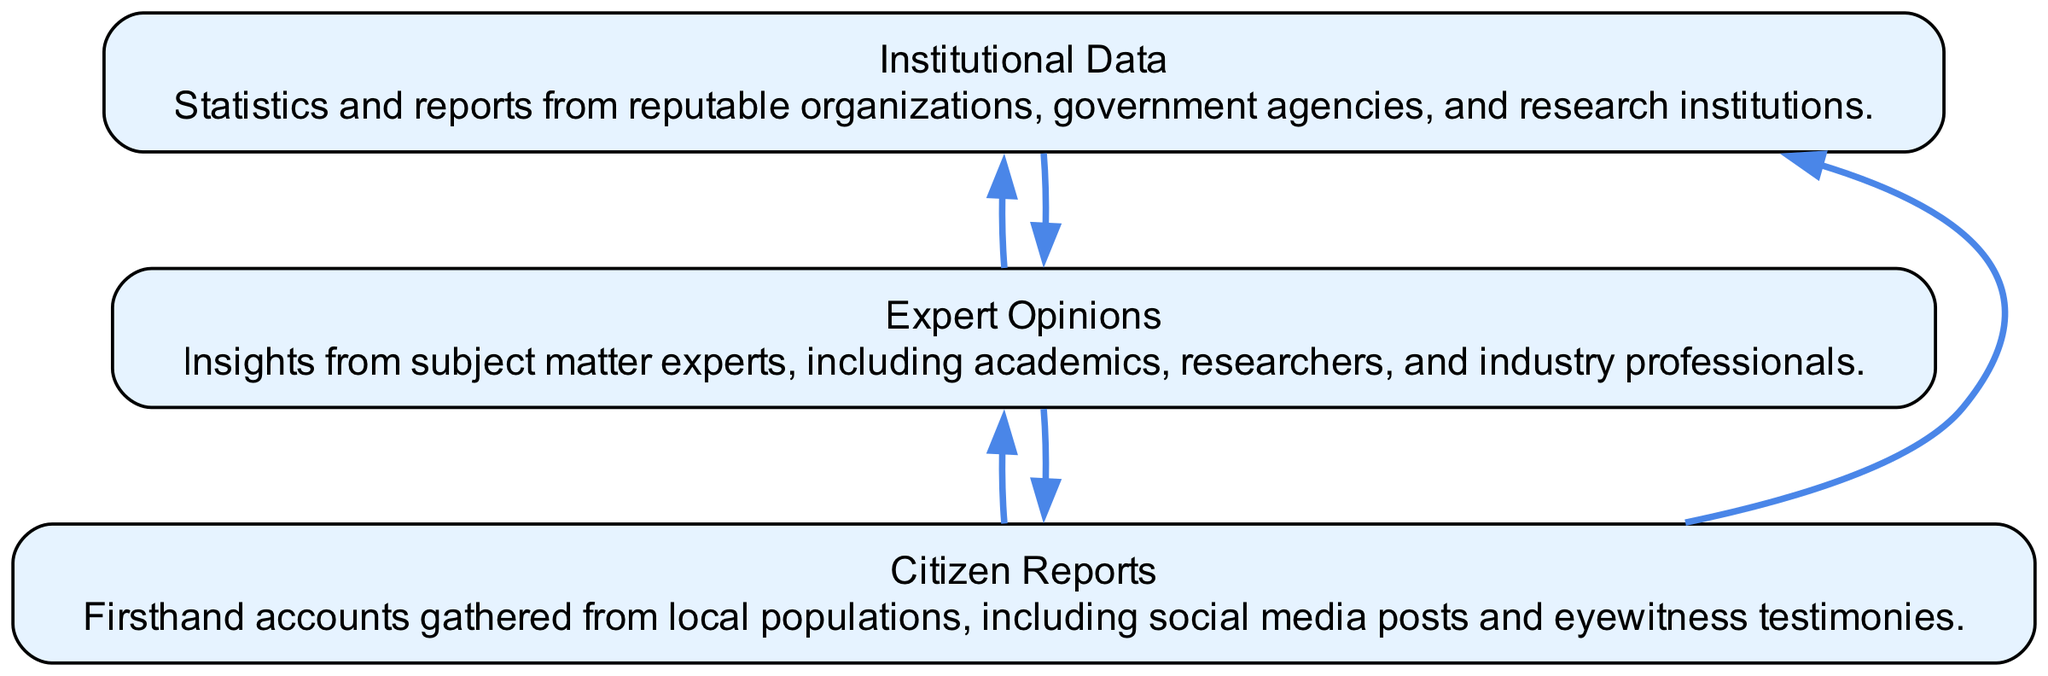What are the three main sources identified in the diagram? The diagram displays three nodes: Citizen Reports, Expert Opinions, and Institutional Data, as it specifically outlines these as key sources for classification.
Answer: Citizen Reports, Expert Opinions, Institutional Data How many connections are there in total in the diagram? By counting the edges in the diagram, each source connects to others. Citizen Reports connects to two sources, Expert Opinions connects to two, and Institutional Data connects to one, resulting in a total of five connections.
Answer: 5 Which source connects to Institutional Data? From the diagram, it is clear that both Expert Opinions and Citizen Reports connect to Institutional Data, but only Expert Opinions directly provides that connection.
Answer: Expert Opinions What type of information do Citizen Reports represent? The description for Citizen Reports in the diagram states that they consist of firsthand accounts gathered from local populations, indicating the type of content these reports provide.
Answer: Firsthand accounts What does the connection flow from Expert Opinions to Citizen Reports imply? The flow from Expert Opinions to Citizen Reports suggests that insights from experts may lead to or influence the collection of citizens' testimonies, indicating a relationship where expert insights can impact public reporting.
Answer: Influence How does Institutional Data function in relation to the other sources? Institutional Data serves as a supporting element that relies on insights from Expert Opinions and potentially informs them as well, showing a collaborative flow where data and expert knowledge work together.
Answer: Supporting element Which node has the most connections in the diagram? By examining the connections, both Citizen Reports and Expert Opinions connect to two other sources, whereas Institutional Data connects to one, meaning Citizen Reports and Expert Opinions are tied for the most connections.
Answer: Citizen Reports, Expert Opinions What primary category does Expert Opinions fall under? The explicit label and description of Expert Opinions categorize them as insights from subject matter experts, which is a clear indication of their primary classification.
Answer: Insights from subject matter experts 